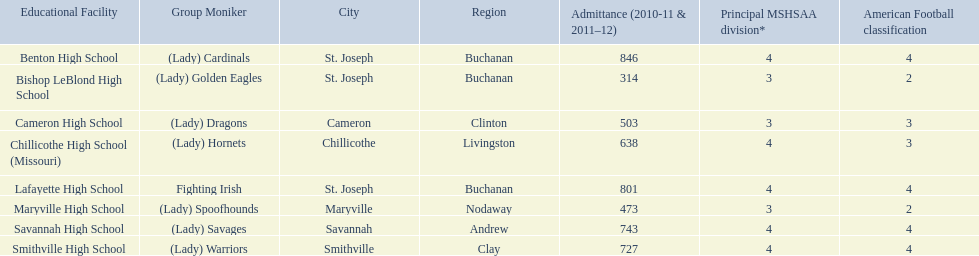Give me the full table as a dictionary. {'header': ['Educational Facility', 'Group Moniker', 'City', 'Region', 'Admittance (2010-11 & 2011–12)', 'Principal MSHSAA division*', 'American Football classification'], 'rows': [['Benton High School', '(Lady) Cardinals', 'St. Joseph', 'Buchanan', '846', '4', '4'], ['Bishop LeBlond High School', '(Lady) Golden Eagles', 'St. Joseph', 'Buchanan', '314', '3', '2'], ['Cameron High School', '(Lady) Dragons', 'Cameron', 'Clinton', '503', '3', '3'], ['Chillicothe High School (Missouri)', '(Lady) Hornets', 'Chillicothe', 'Livingston', '638', '4', '3'], ['Lafayette High School', 'Fighting Irish', 'St. Joseph', 'Buchanan', '801', '4', '4'], ['Maryville High School', '(Lady) Spoofhounds', 'Maryville', 'Nodaway', '473', '3', '2'], ['Savannah High School', '(Lady) Savages', 'Savannah', 'Andrew', '743', '4', '4'], ['Smithville High School', '(Lady) Warriors', 'Smithville', 'Clay', '727', '4', '4']]} What team uses green and grey as colors? Fighting Irish. What is this team called? Lafayette High School. 